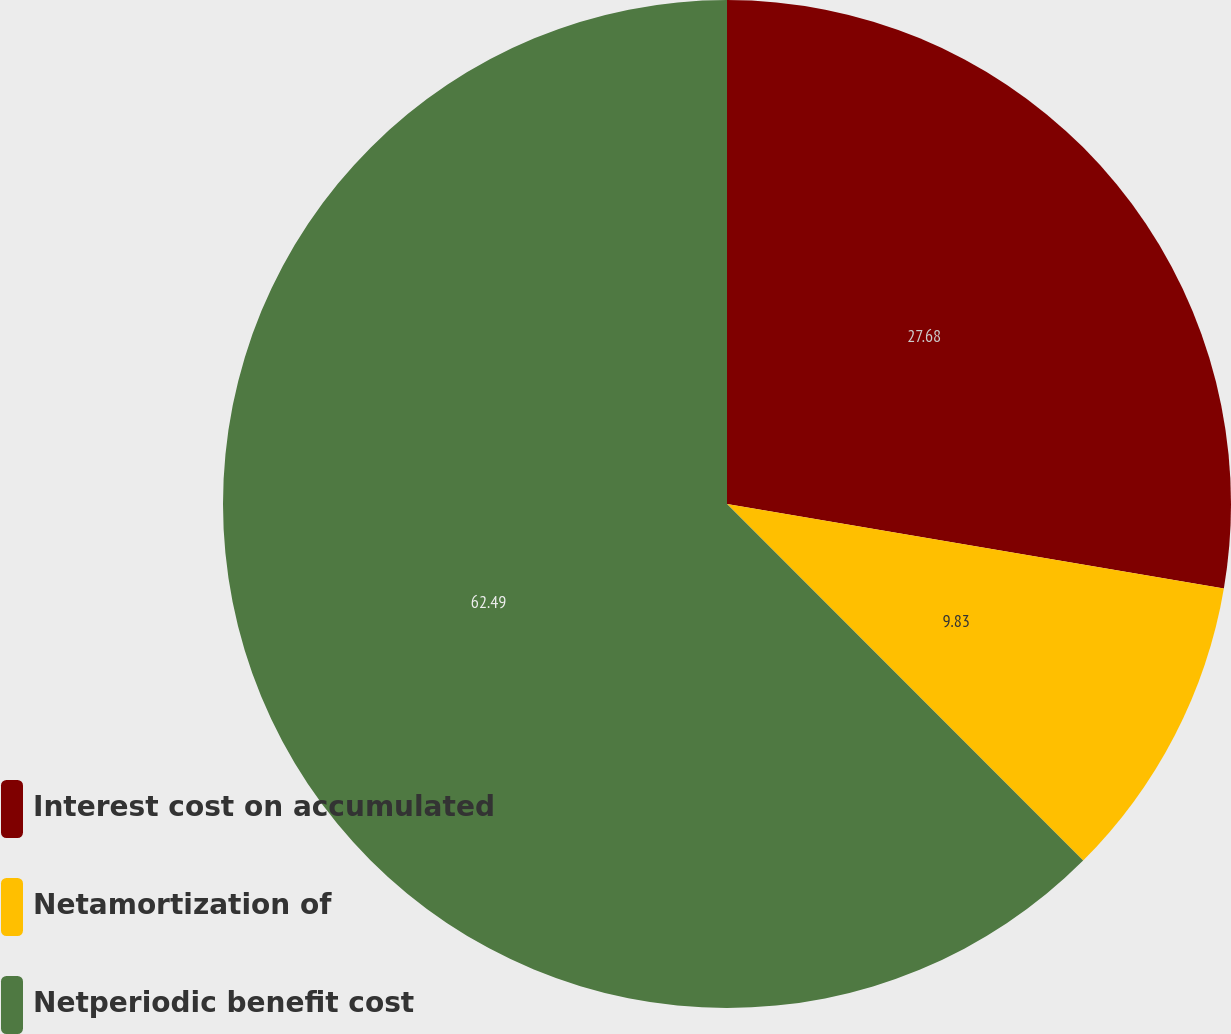Convert chart. <chart><loc_0><loc_0><loc_500><loc_500><pie_chart><fcel>Interest cost on accumulated<fcel>Netamortization of<fcel>Netperiodic benefit cost<nl><fcel>27.68%<fcel>9.83%<fcel>62.49%<nl></chart> 